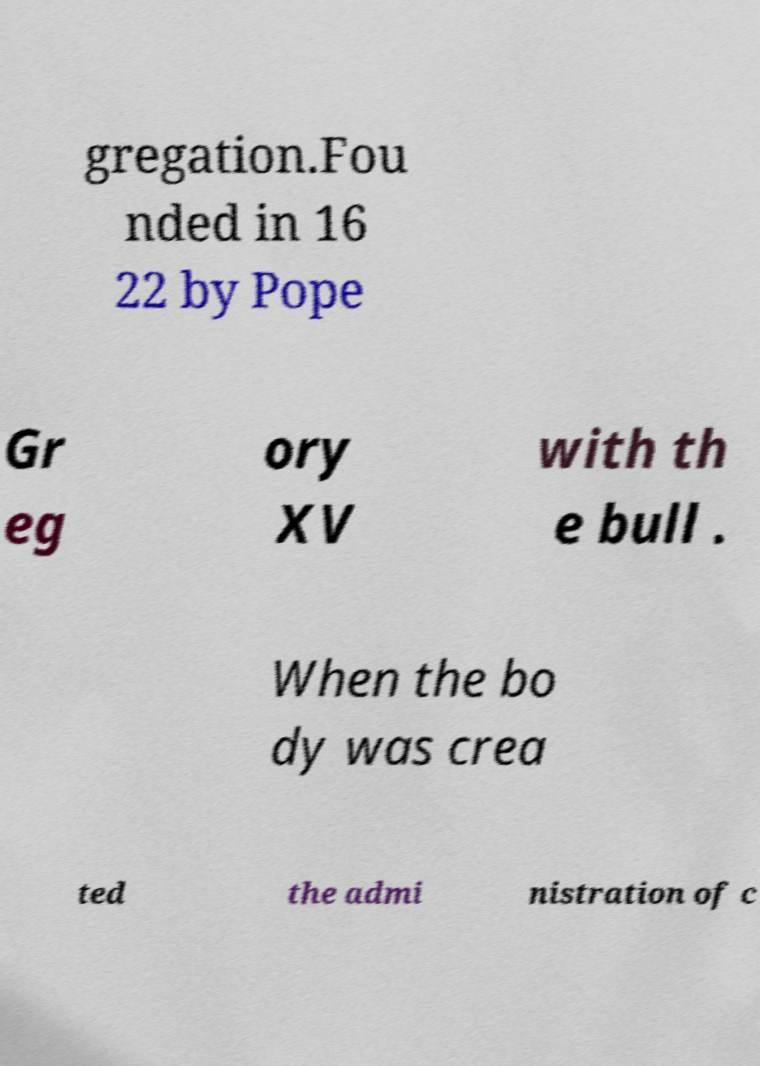There's text embedded in this image that I need extracted. Can you transcribe it verbatim? gregation.Fou nded in 16 22 by Pope Gr eg ory XV with th e bull . When the bo dy was crea ted the admi nistration of c 